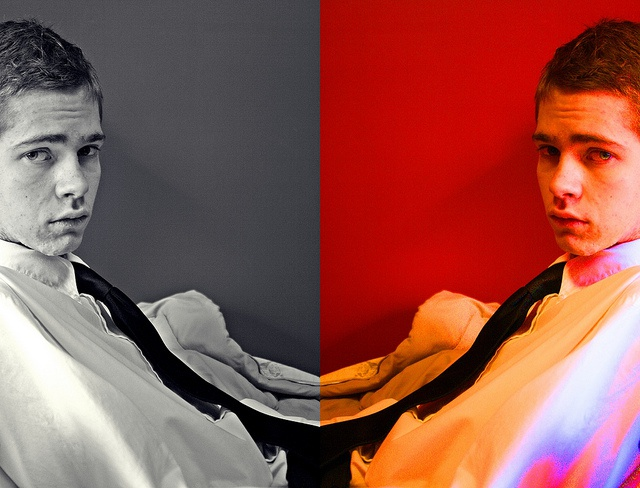Describe the objects in this image and their specific colors. I can see people in gray, darkgray, ivory, and black tones, people in gray, orange, lavender, red, and black tones, tie in gray, black, maroon, orange, and red tones, and tie in gray, black, lightgray, and darkgray tones in this image. 